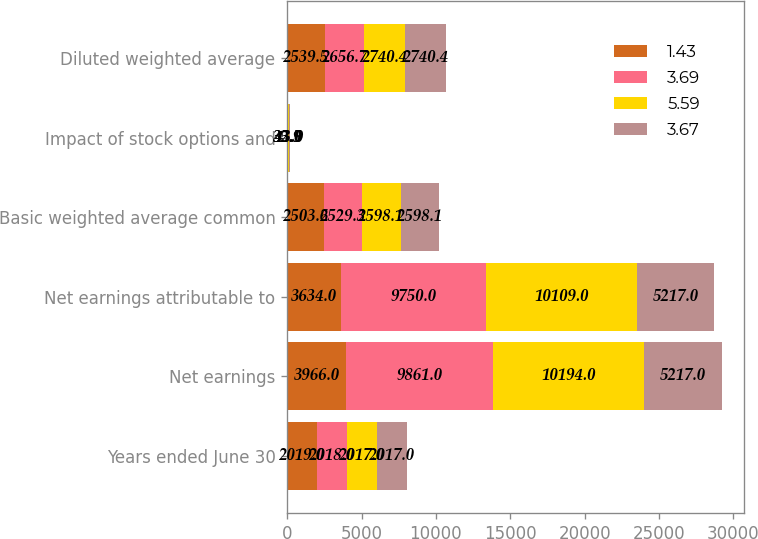Convert chart. <chart><loc_0><loc_0><loc_500><loc_500><stacked_bar_chart><ecel><fcel>Years ended June 30<fcel>Net earnings<fcel>Net earnings attributable to<fcel>Basic weighted average common<fcel>Impact of stock options and<fcel>Diluted weighted average<nl><fcel>1.43<fcel>2019<fcel>3966<fcel>3634<fcel>2503.6<fcel>35.9<fcel>2539.5<nl><fcel>3.69<fcel>2018<fcel>9861<fcel>9750<fcel>2529.3<fcel>32.5<fcel>2656.7<nl><fcel>5.59<fcel>2017<fcel>10194<fcel>10109<fcel>2598.1<fcel>43<fcel>2740.4<nl><fcel>3.67<fcel>2017<fcel>5217<fcel>5217<fcel>2598.1<fcel>43<fcel>2740.4<nl></chart> 